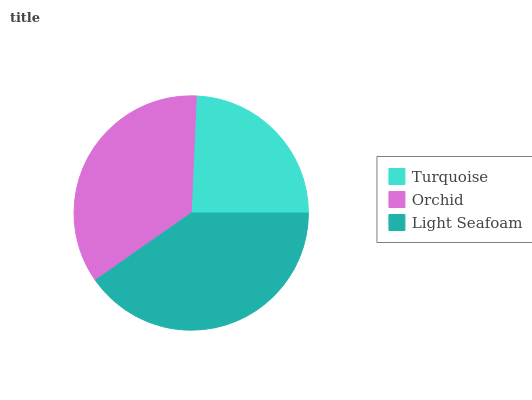Is Turquoise the minimum?
Answer yes or no. Yes. Is Light Seafoam the maximum?
Answer yes or no. Yes. Is Orchid the minimum?
Answer yes or no. No. Is Orchid the maximum?
Answer yes or no. No. Is Orchid greater than Turquoise?
Answer yes or no. Yes. Is Turquoise less than Orchid?
Answer yes or no. Yes. Is Turquoise greater than Orchid?
Answer yes or no. No. Is Orchid less than Turquoise?
Answer yes or no. No. Is Orchid the high median?
Answer yes or no. Yes. Is Orchid the low median?
Answer yes or no. Yes. Is Light Seafoam the high median?
Answer yes or no. No. Is Turquoise the low median?
Answer yes or no. No. 